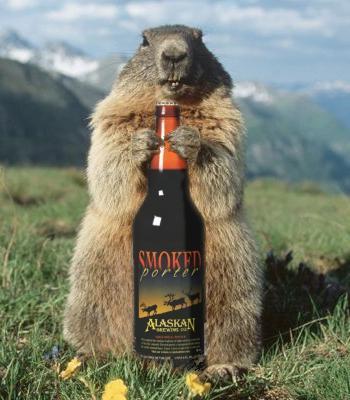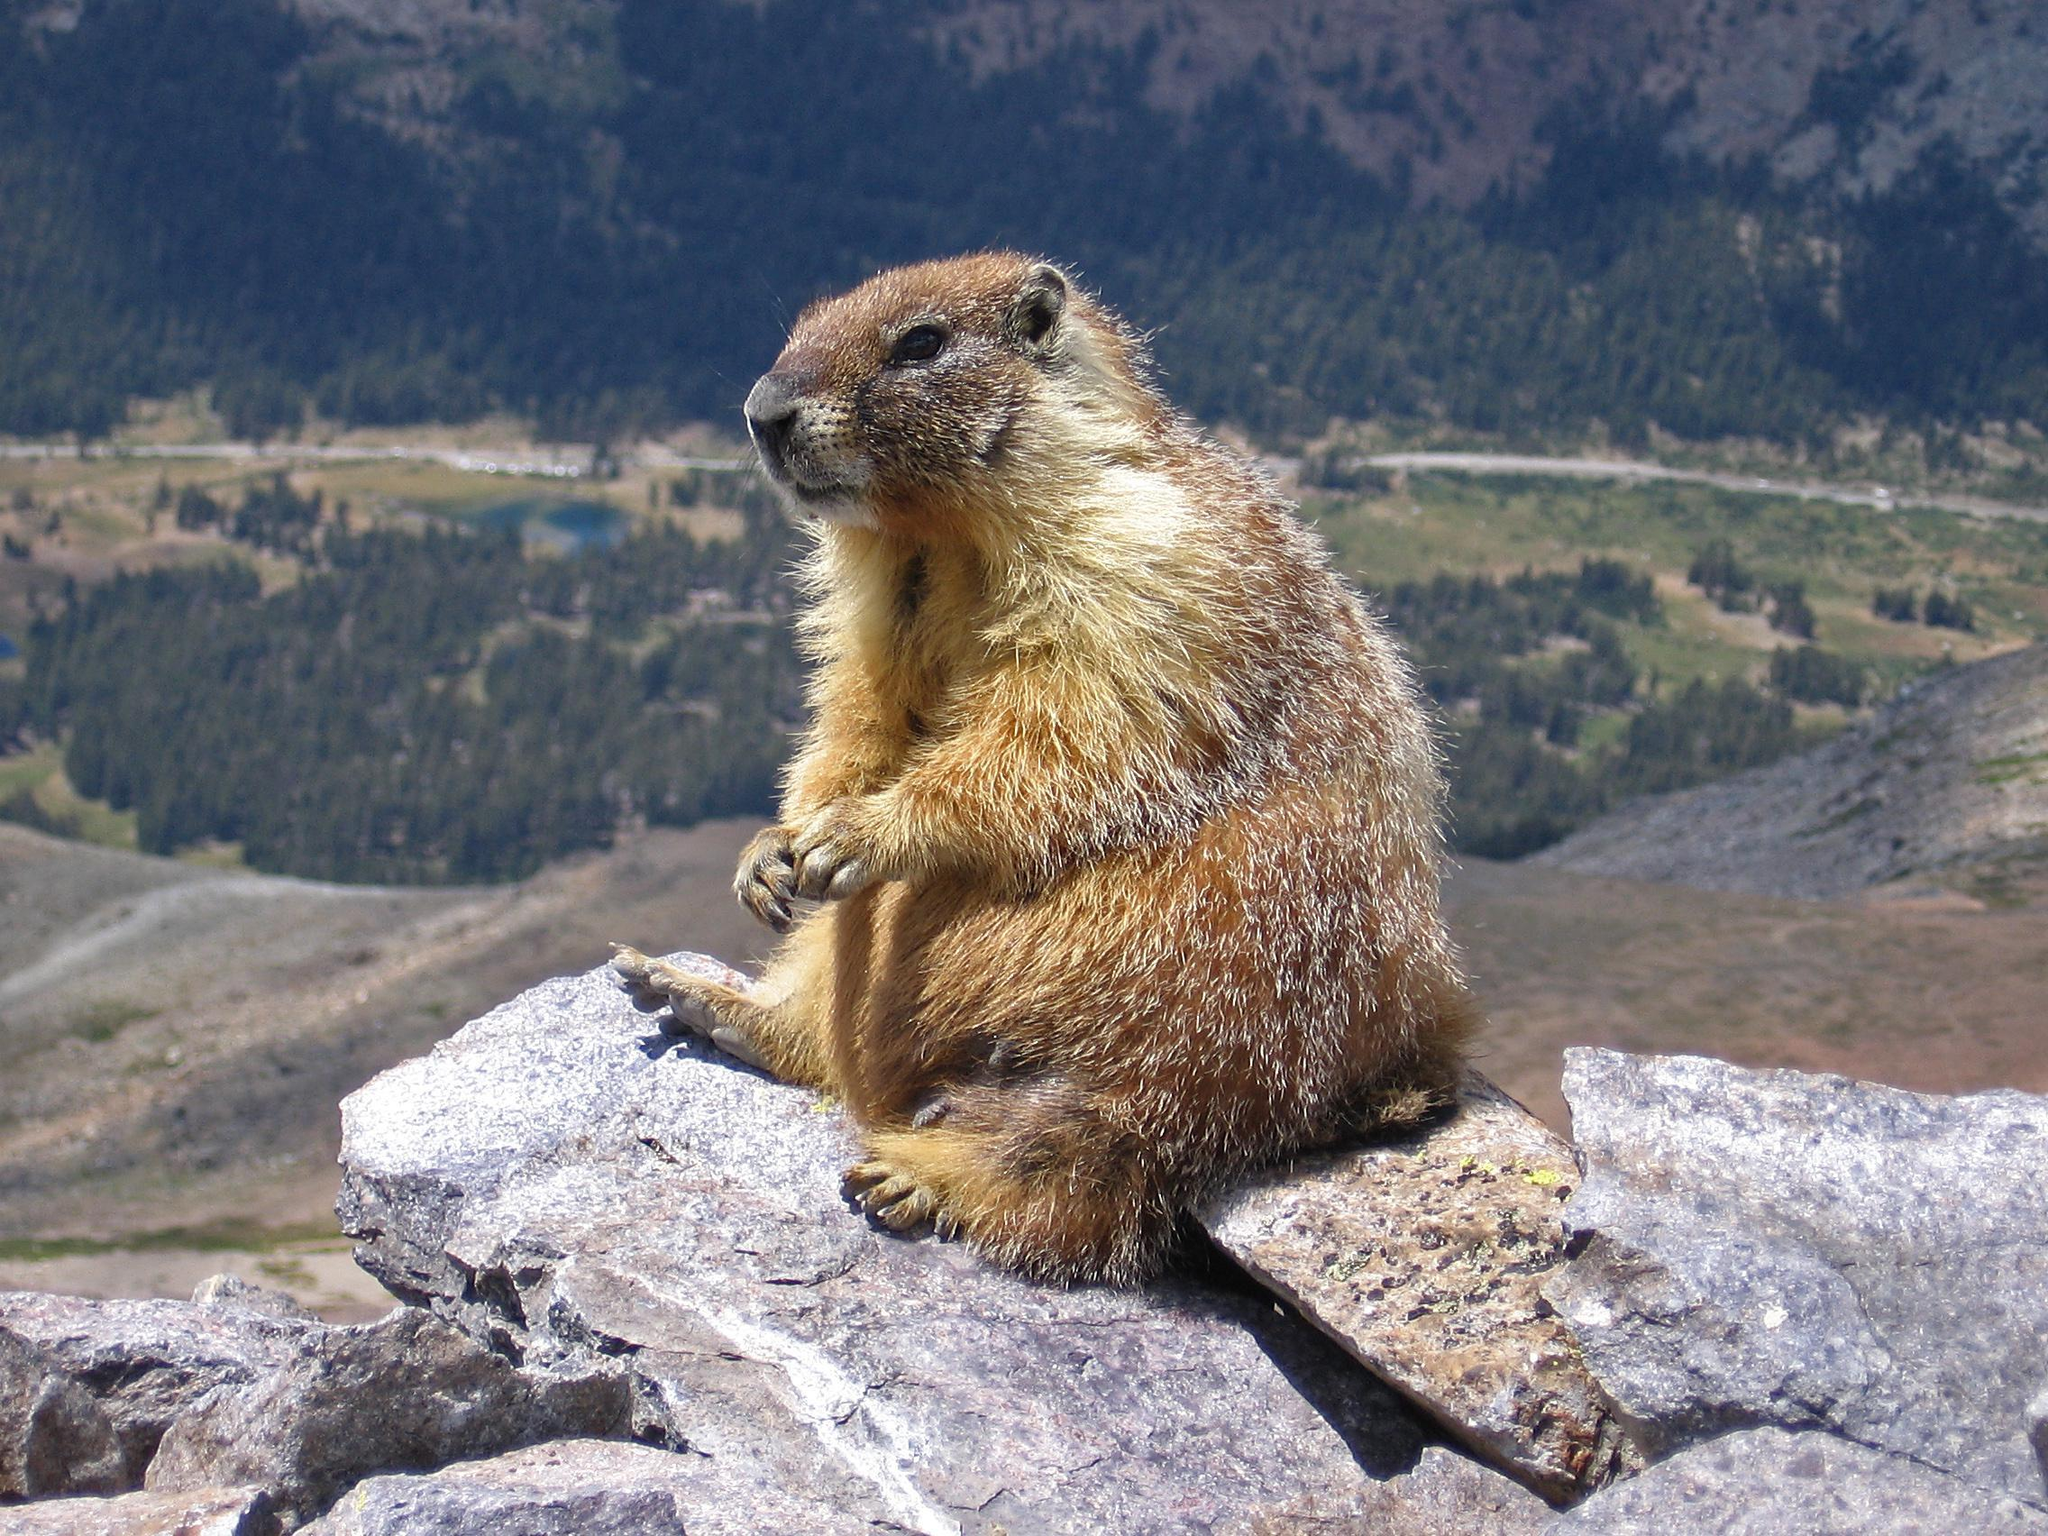The first image is the image on the left, the second image is the image on the right. Given the left and right images, does the statement "There is at least one animal standing on its hind legs holding something in its front paws." hold true? Answer yes or no. Yes. The first image is the image on the left, the second image is the image on the right. For the images displayed, is the sentence "An image contains at least twice as many marmots as the other image." factually correct? Answer yes or no. No. 